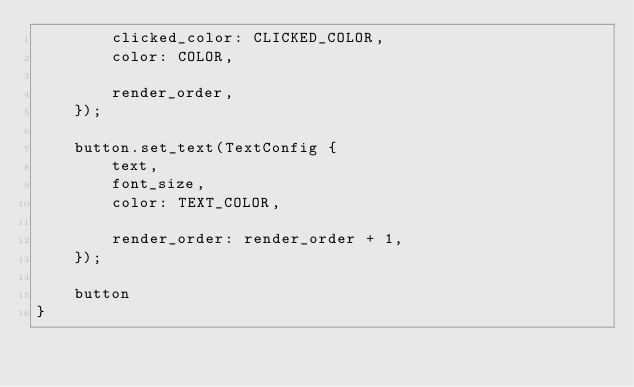Convert code to text. <code><loc_0><loc_0><loc_500><loc_500><_Rust_>        clicked_color: CLICKED_COLOR,
        color: COLOR,

        render_order,
    });

    button.set_text(TextConfig {
        text,
        font_size,
        color: TEXT_COLOR,

        render_order: render_order + 1,
    });

    button
}
</code> 